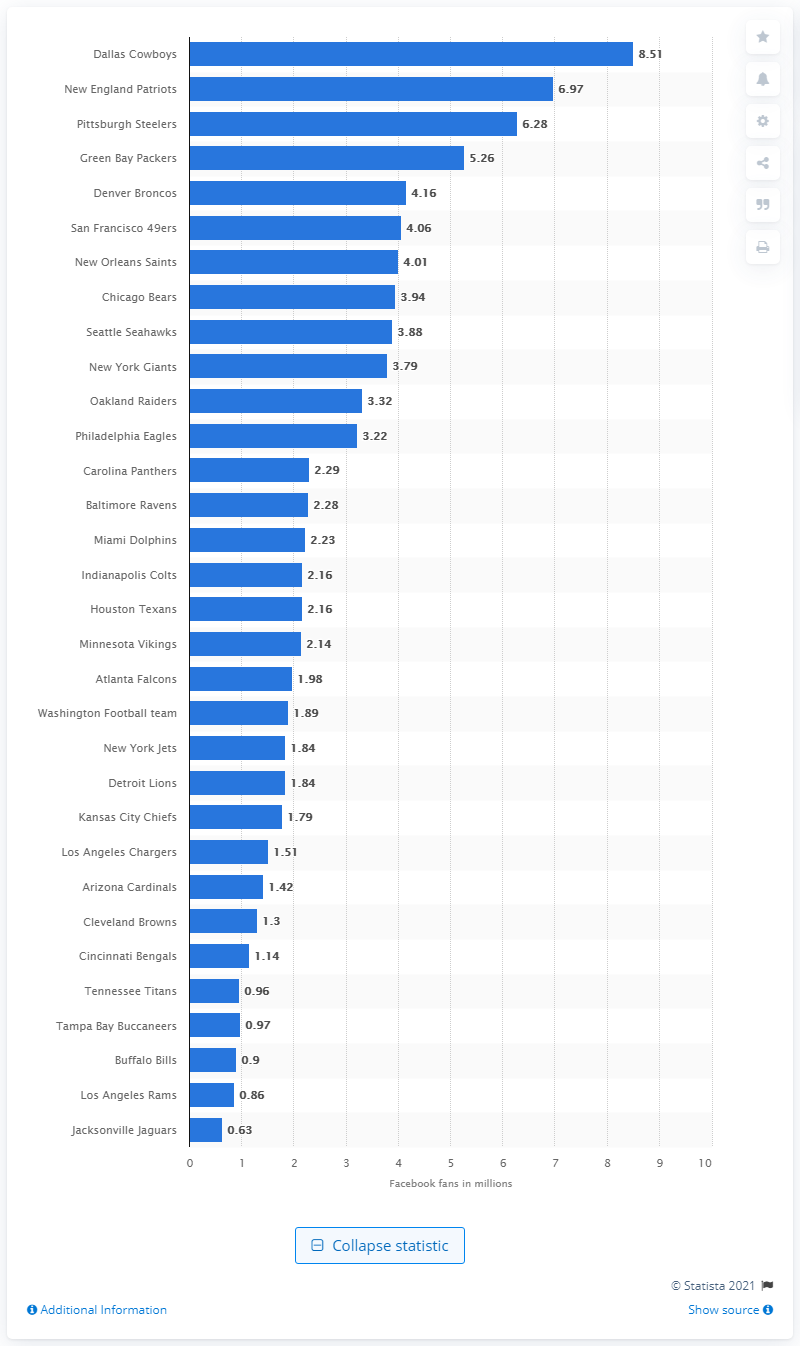Point out several critical features in this image. The Dallas Cowboys have 8,510 fans on Facebook. The New England Patriots are the second most followed NFL team on Facebook. 